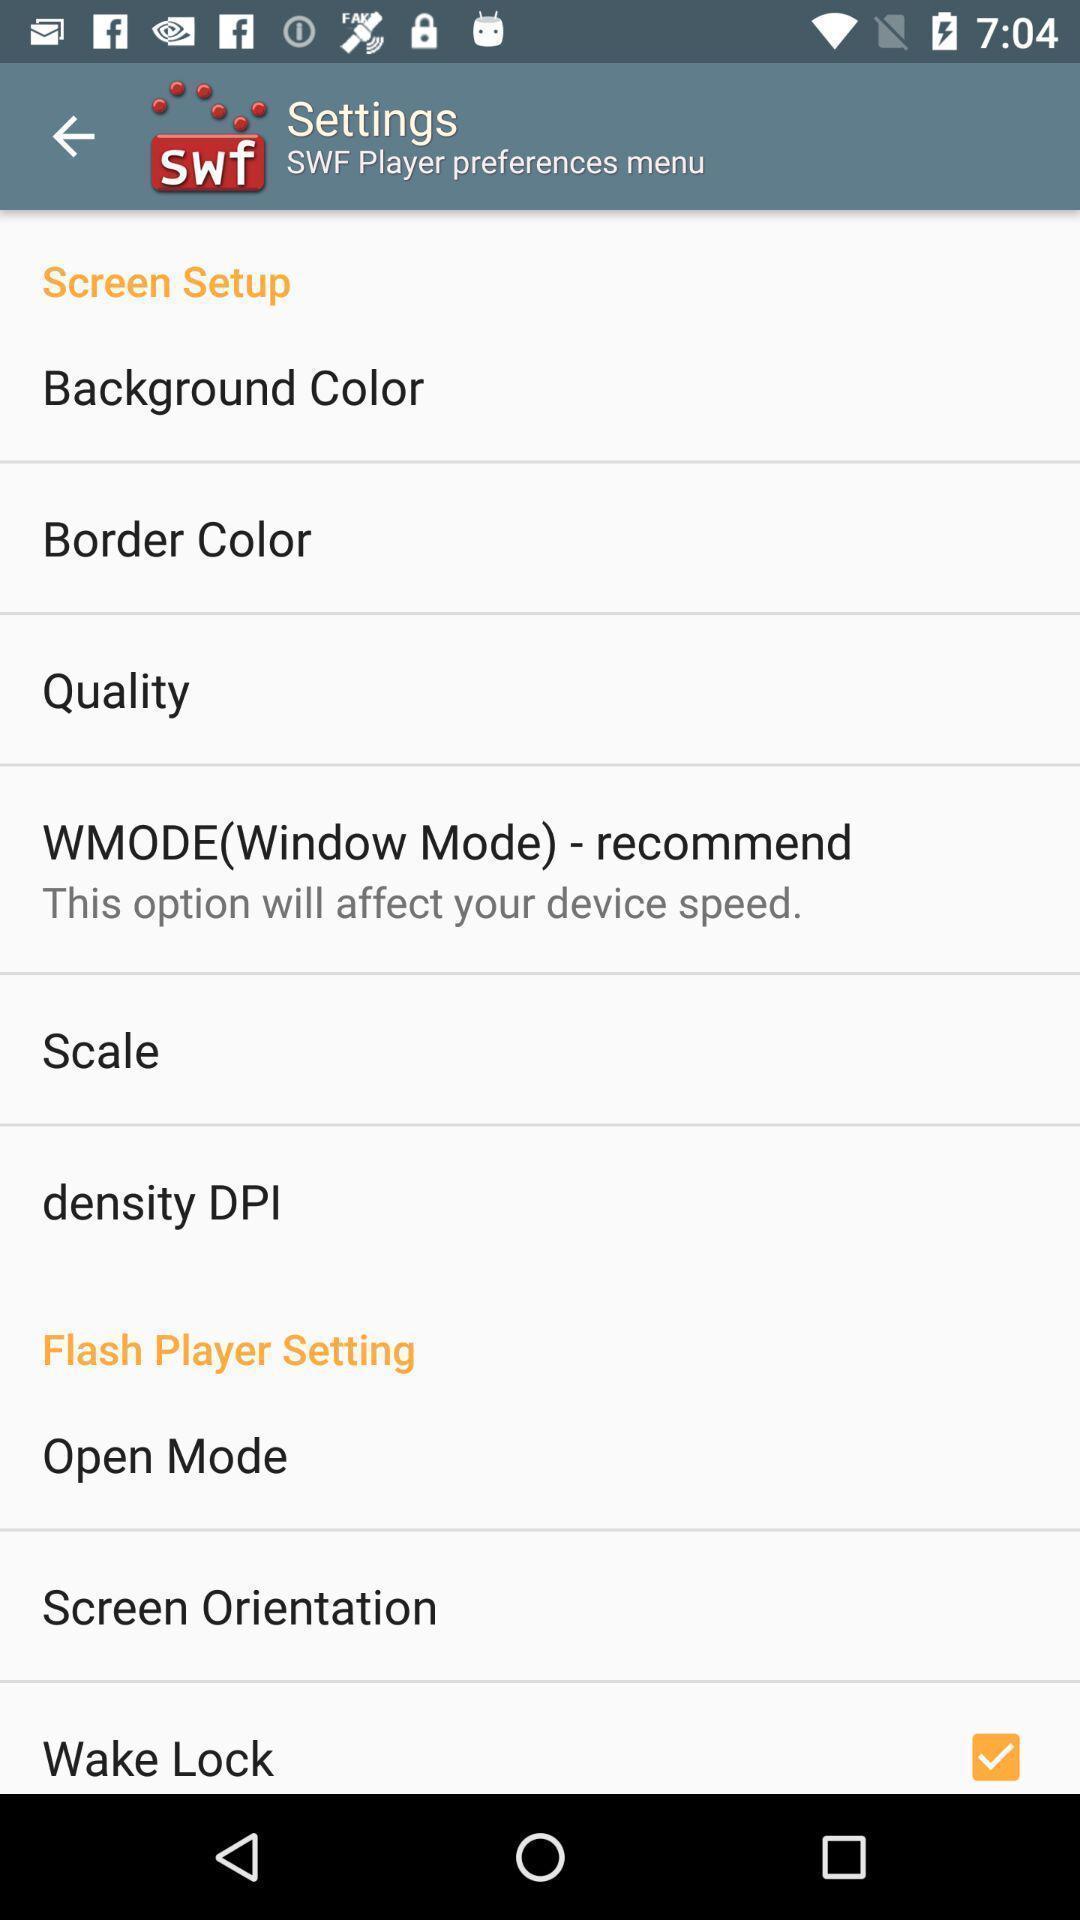Describe the content in this image. Settings page of a profile with several options. 